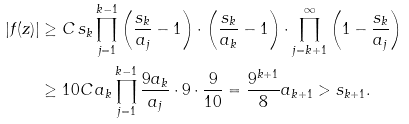<formula> <loc_0><loc_0><loc_500><loc_500>| f ( z ) | & \geq C \, s _ { k } \prod _ { j = 1 } ^ { k - 1 } \left ( \frac { s _ { k } } { a _ { j } } - 1 \right ) \cdot \left ( \frac { s _ { k } } { a _ { k } } - 1 \right ) \cdot \prod _ { j = k + 1 } ^ { \infty } \left ( 1 - \frac { s _ { k } } { a _ { j } } \right ) \\ & \geq 1 0 C \, a _ { k } \prod _ { j = 1 } ^ { k - 1 } \frac { 9 a _ { k } } { a _ { j } } \cdot 9 \cdot \frac { 9 } { 1 0 } = \frac { 9 ^ { k + 1 } } { 8 } a _ { k + 1 } > s _ { k + 1 } .</formula> 